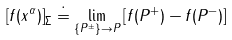<formula> <loc_0><loc_0><loc_500><loc_500>\left [ f ( x ^ { \alpha } ) \right ] _ { \Sigma } \doteq \lim _ { \{ P ^ { \pm } \} \rightarrow P } \left [ f ( P ^ { + } ) - f ( P ^ { - } ) \right ]</formula> 